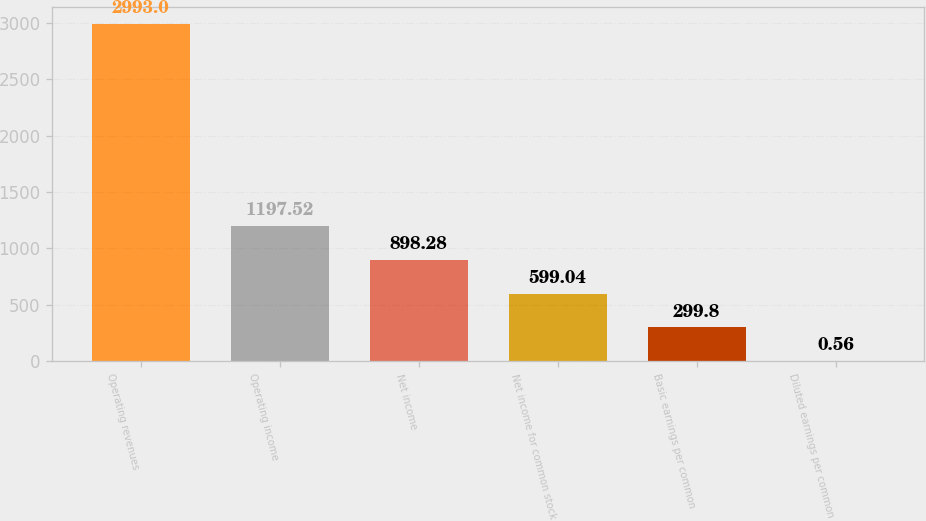Convert chart. <chart><loc_0><loc_0><loc_500><loc_500><bar_chart><fcel>Operating revenues<fcel>Operating income<fcel>Net income<fcel>Net income for common stock<fcel>Basic earnings per common<fcel>Diluted earnings per common<nl><fcel>2993<fcel>1197.52<fcel>898.28<fcel>599.04<fcel>299.8<fcel>0.56<nl></chart> 